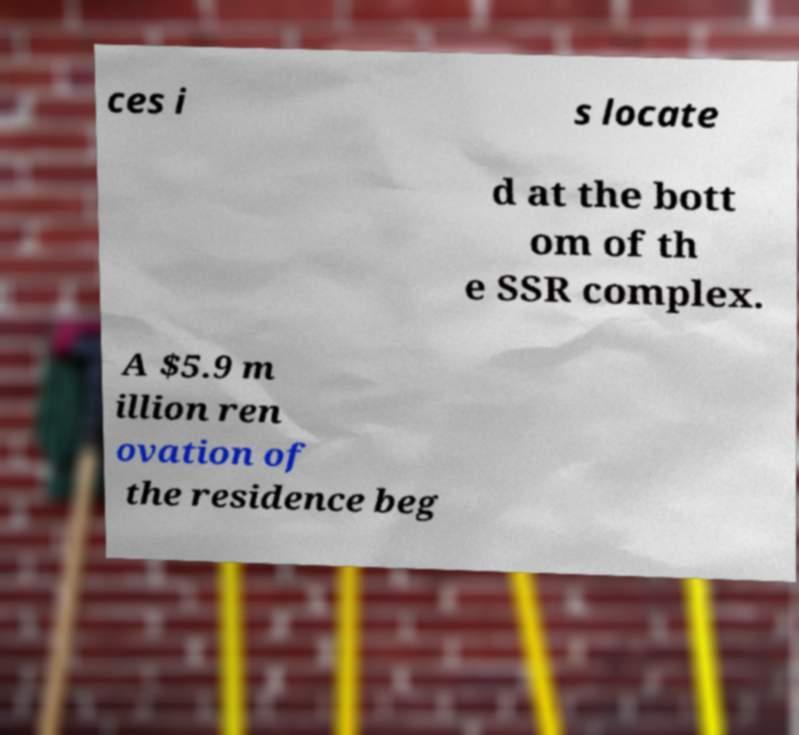Please identify and transcribe the text found in this image. ces i s locate d at the bott om of th e SSR complex. A $5.9 m illion ren ovation of the residence beg 